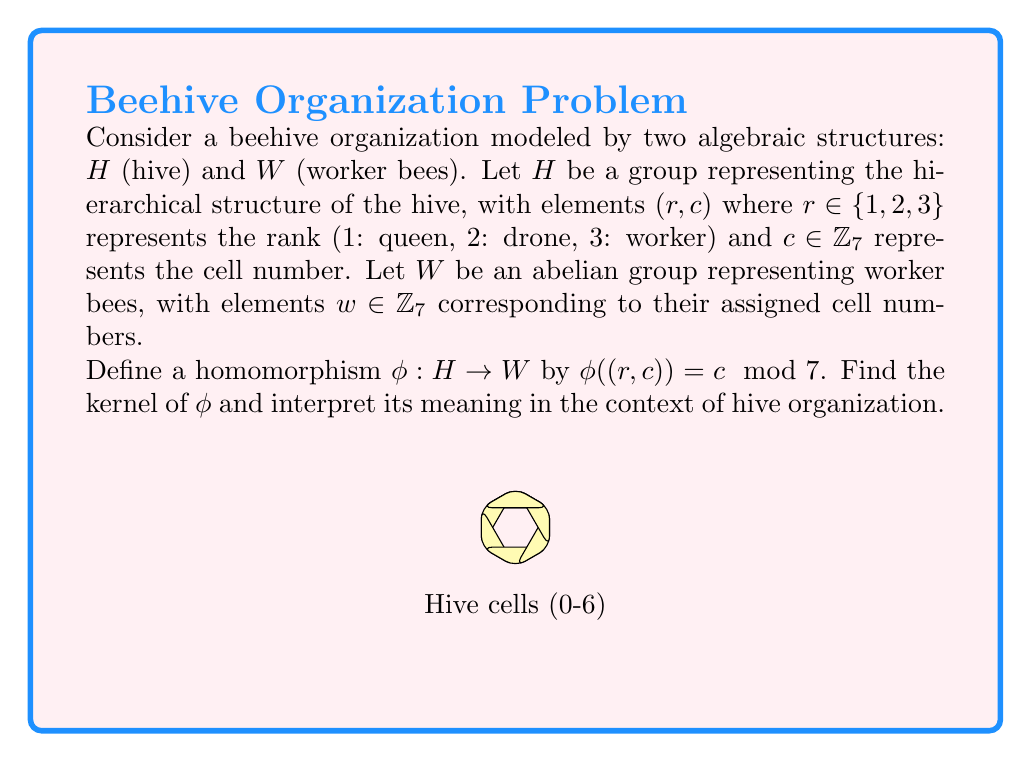Help me with this question. To find the kernel of the homomorphism $\phi$, we need to determine all elements in $H$ that map to the identity element in $W$.

Step 1: Identify the identity element in $W$.
The identity element in $W$ (which is $\mathbb{Z}_7$) is 0.

Step 2: Find all elements in $H$ that map to 0 in $W$.
$\phi((r, c)) = 0 \mod 7$ when $c \equiv 0 \mod 7$.

Step 3: List all elements in $H$ that satisfy this condition.
These are all elements of the form $(r, 0)$ where $r \in \{1, 2, 3\}$.

Step 4: Express the kernel as a set.
$\ker(\phi) = \{(1, 0), (2, 0), (3, 0)\}$

Step 5: Interpret the meaning in the context of hive organization.
The kernel represents all bees (queen, drone, and worker) assigned to cell 0. These bees are indistinguishable from the perspective of their cell assignment, despite their different ranks in the hive hierarchy.
Answer: $\ker(\phi) = \{(1, 0), (2, 0), (3, 0)\}$ 